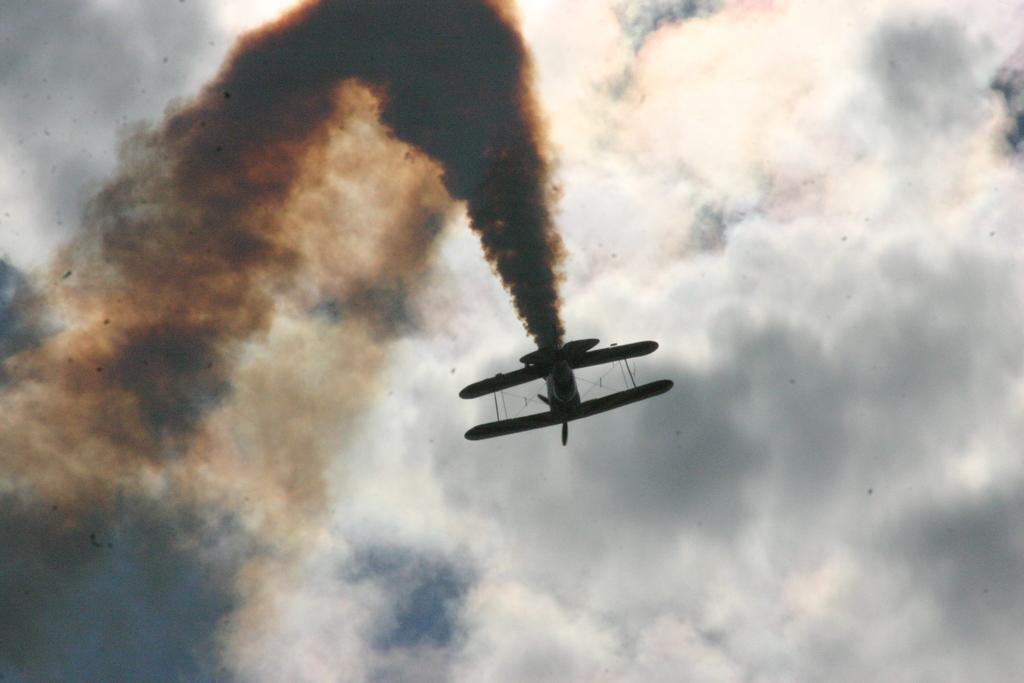Can you describe this image briefly? In this image we can see a jet plane with some smoke in the sky. The sky looks cloudy. 